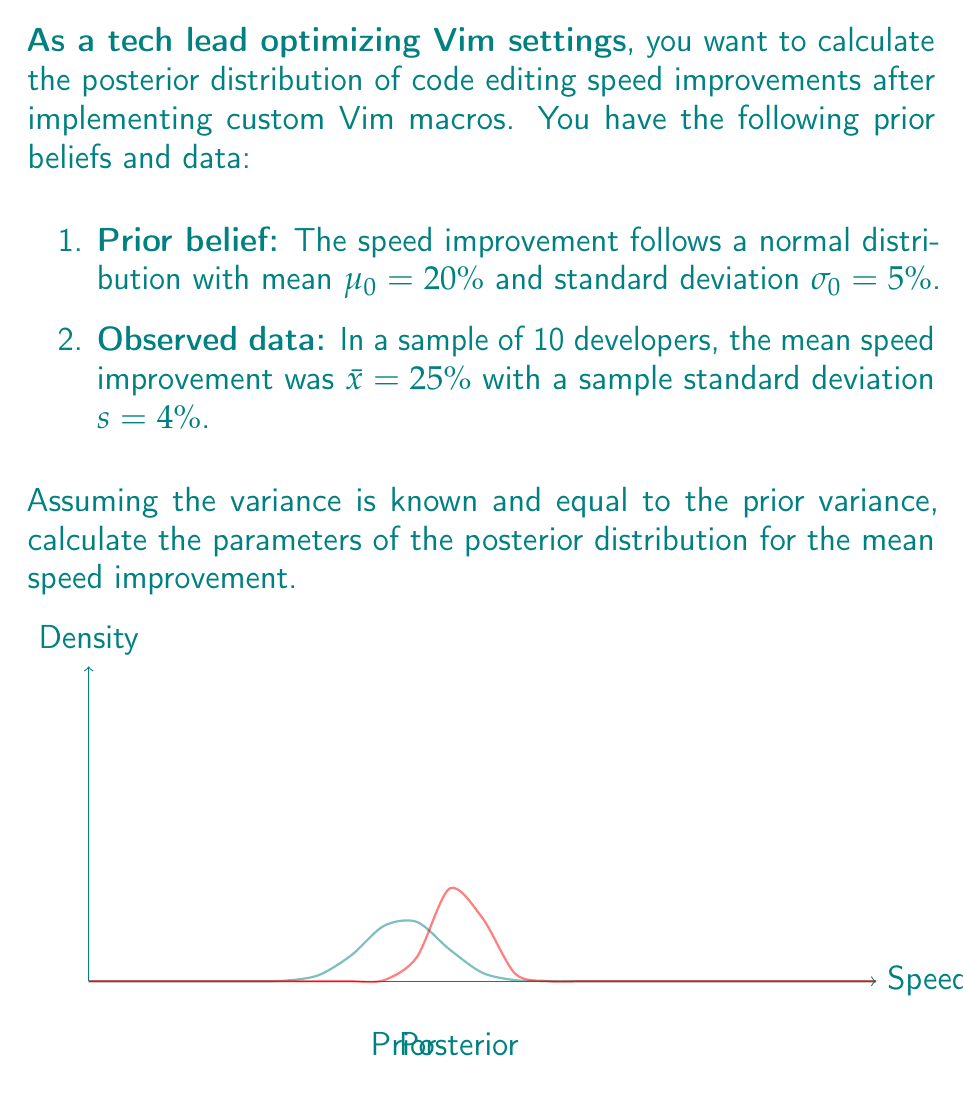Give your solution to this math problem. To solve this problem, we'll use the Bayesian updating formula for normal distributions with known variance. The steps are as follows:

1. Identify the prior distribution:
   $\mu_0 = 20\%$, $\sigma_0 = 5\%$

2. Identify the likelihood (sample data):
   $\bar{x} = 25\%$, $n = 10$, $s = 4\%$

3. Calculate the posterior parameters using the following formulas:

   $$\mu_N = \frac{\frac{\mu_0}{\sigma_0^2} + \frac{n\bar{x}}{\sigma_0^2}}{\frac{1}{\sigma_0^2} + \frac{n}{\sigma_0^2}}$$

   $$\sigma_N^2 = \frac{1}{\frac{1}{\sigma_0^2} + \frac{n}{\sigma_0^2}}$$

4. Substitute the values:

   $$\mu_N = \frac{\frac{20}{5^2} + \frac{10 \cdot 25}{5^2}}{\frac{1}{5^2} + \frac{10}{5^2}} = \frac{0.8 + 10}{0.04 + 0.4} = \frac{10.8}{0.44} \approx 23.57\%$$

   $$\sigma_N^2 = \frac{1}{\frac{1}{5^2} + \frac{10}{5^2}} = \frac{1}{0.44} \approx 2.27$$

   $$\sigma_N = \sqrt{2.27} \approx 1.51\%$$

5. The posterior distribution is therefore normal with mean $\mu_N \approx 23.57\%$ and standard deviation $\sigma_N \approx 1.51\%$.

This result shows that after observing the data, our belief about the mean speed improvement has shifted towards the observed mean and become more certain (smaller standard deviation).
Answer: $\mu_N \approx 23.57\%$, $\sigma_N \approx 1.51\%$ 